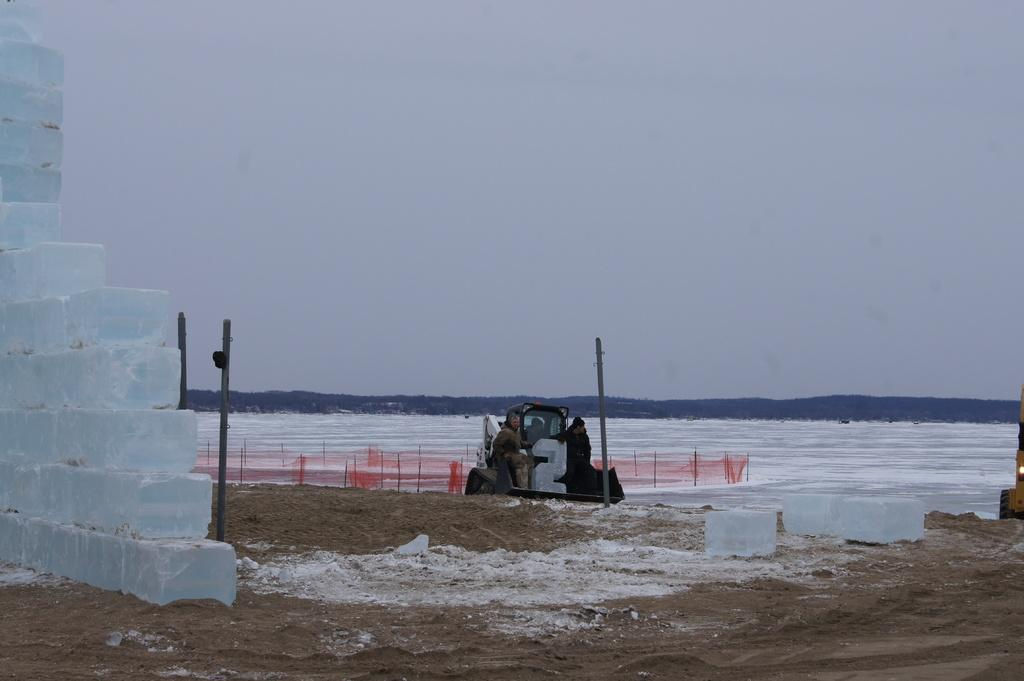What types of objects are present in the image? There are vehicles and people in the image. Where are the blocks and metal rods located in the image? The blocks and metal rods are on the left side of the image. What is the name of the mom in the image? There is no mom present in the image. What holiday is being celebrated in the image? There is no indication of a holiday being celebrated in the image. 